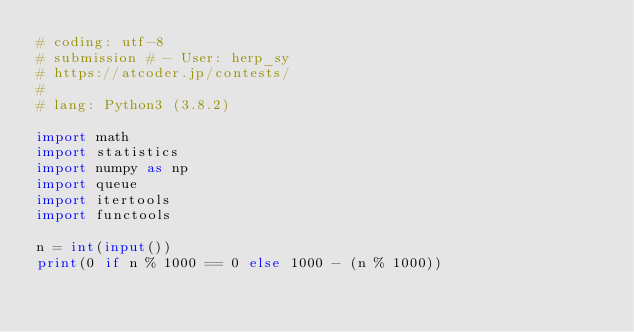Convert code to text. <code><loc_0><loc_0><loc_500><loc_500><_Python_># coding: utf-8
# submission # - User: herp_sy
# https://atcoder.jp/contests/
#
# lang: Python3 (3.8.2)

import math
import statistics
import numpy as np
import queue
import itertools
import functools 

n = int(input())
print(0 if n % 1000 == 0 else 1000 - (n % 1000))
</code> 